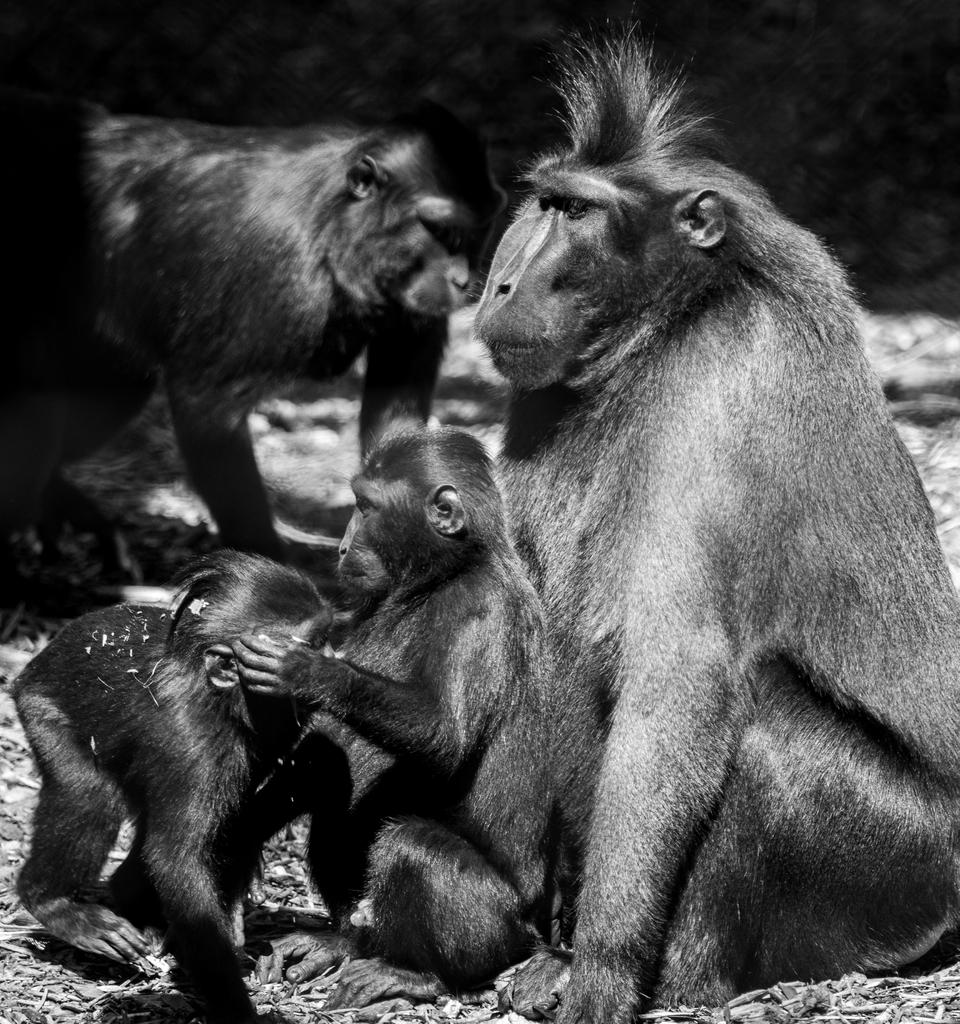What is the color scheme of the image? The image is black and white. What animals are present in the image? There are monkeys in the image. What type of natural elements can be seen on the ground in the image? There are dry leaves on the ground in the image. Can you tell me how many geese are visible in the image? There are no geese present in the image; it features monkeys. What type of waste can be seen in the image? There is no waste present in the image; it features monkeys and dry leaves on the ground. 